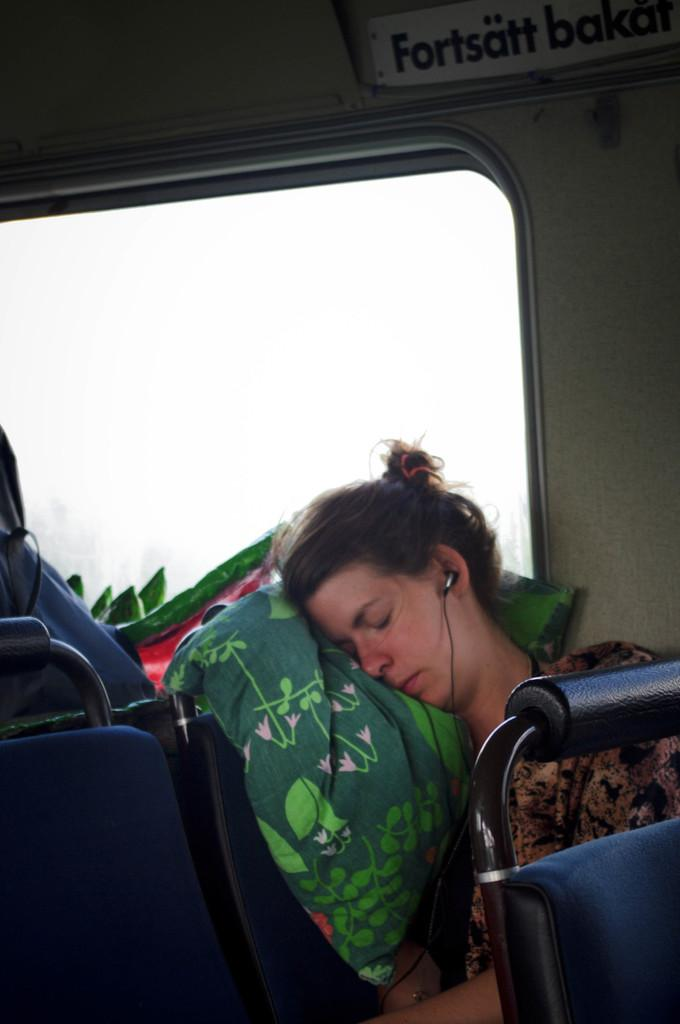Who is present in the image? There is a woman in the image. What is the woman doing in the image? The woman is sleeping in the image. What is the woman sitting on in the image? The woman is sitting in a seat in the image. What color is the pillow the woman is using? The woman is using a green color pillow in the image. What color are the seats in the image? The seats are blue in color in the image. What can be seen behind the woman in the image? There is a window visible behind the woman in the image. What type of structure is the woman teaching in the image? There is no indication in the image that the woman is teaching, nor is there any structure visible. 